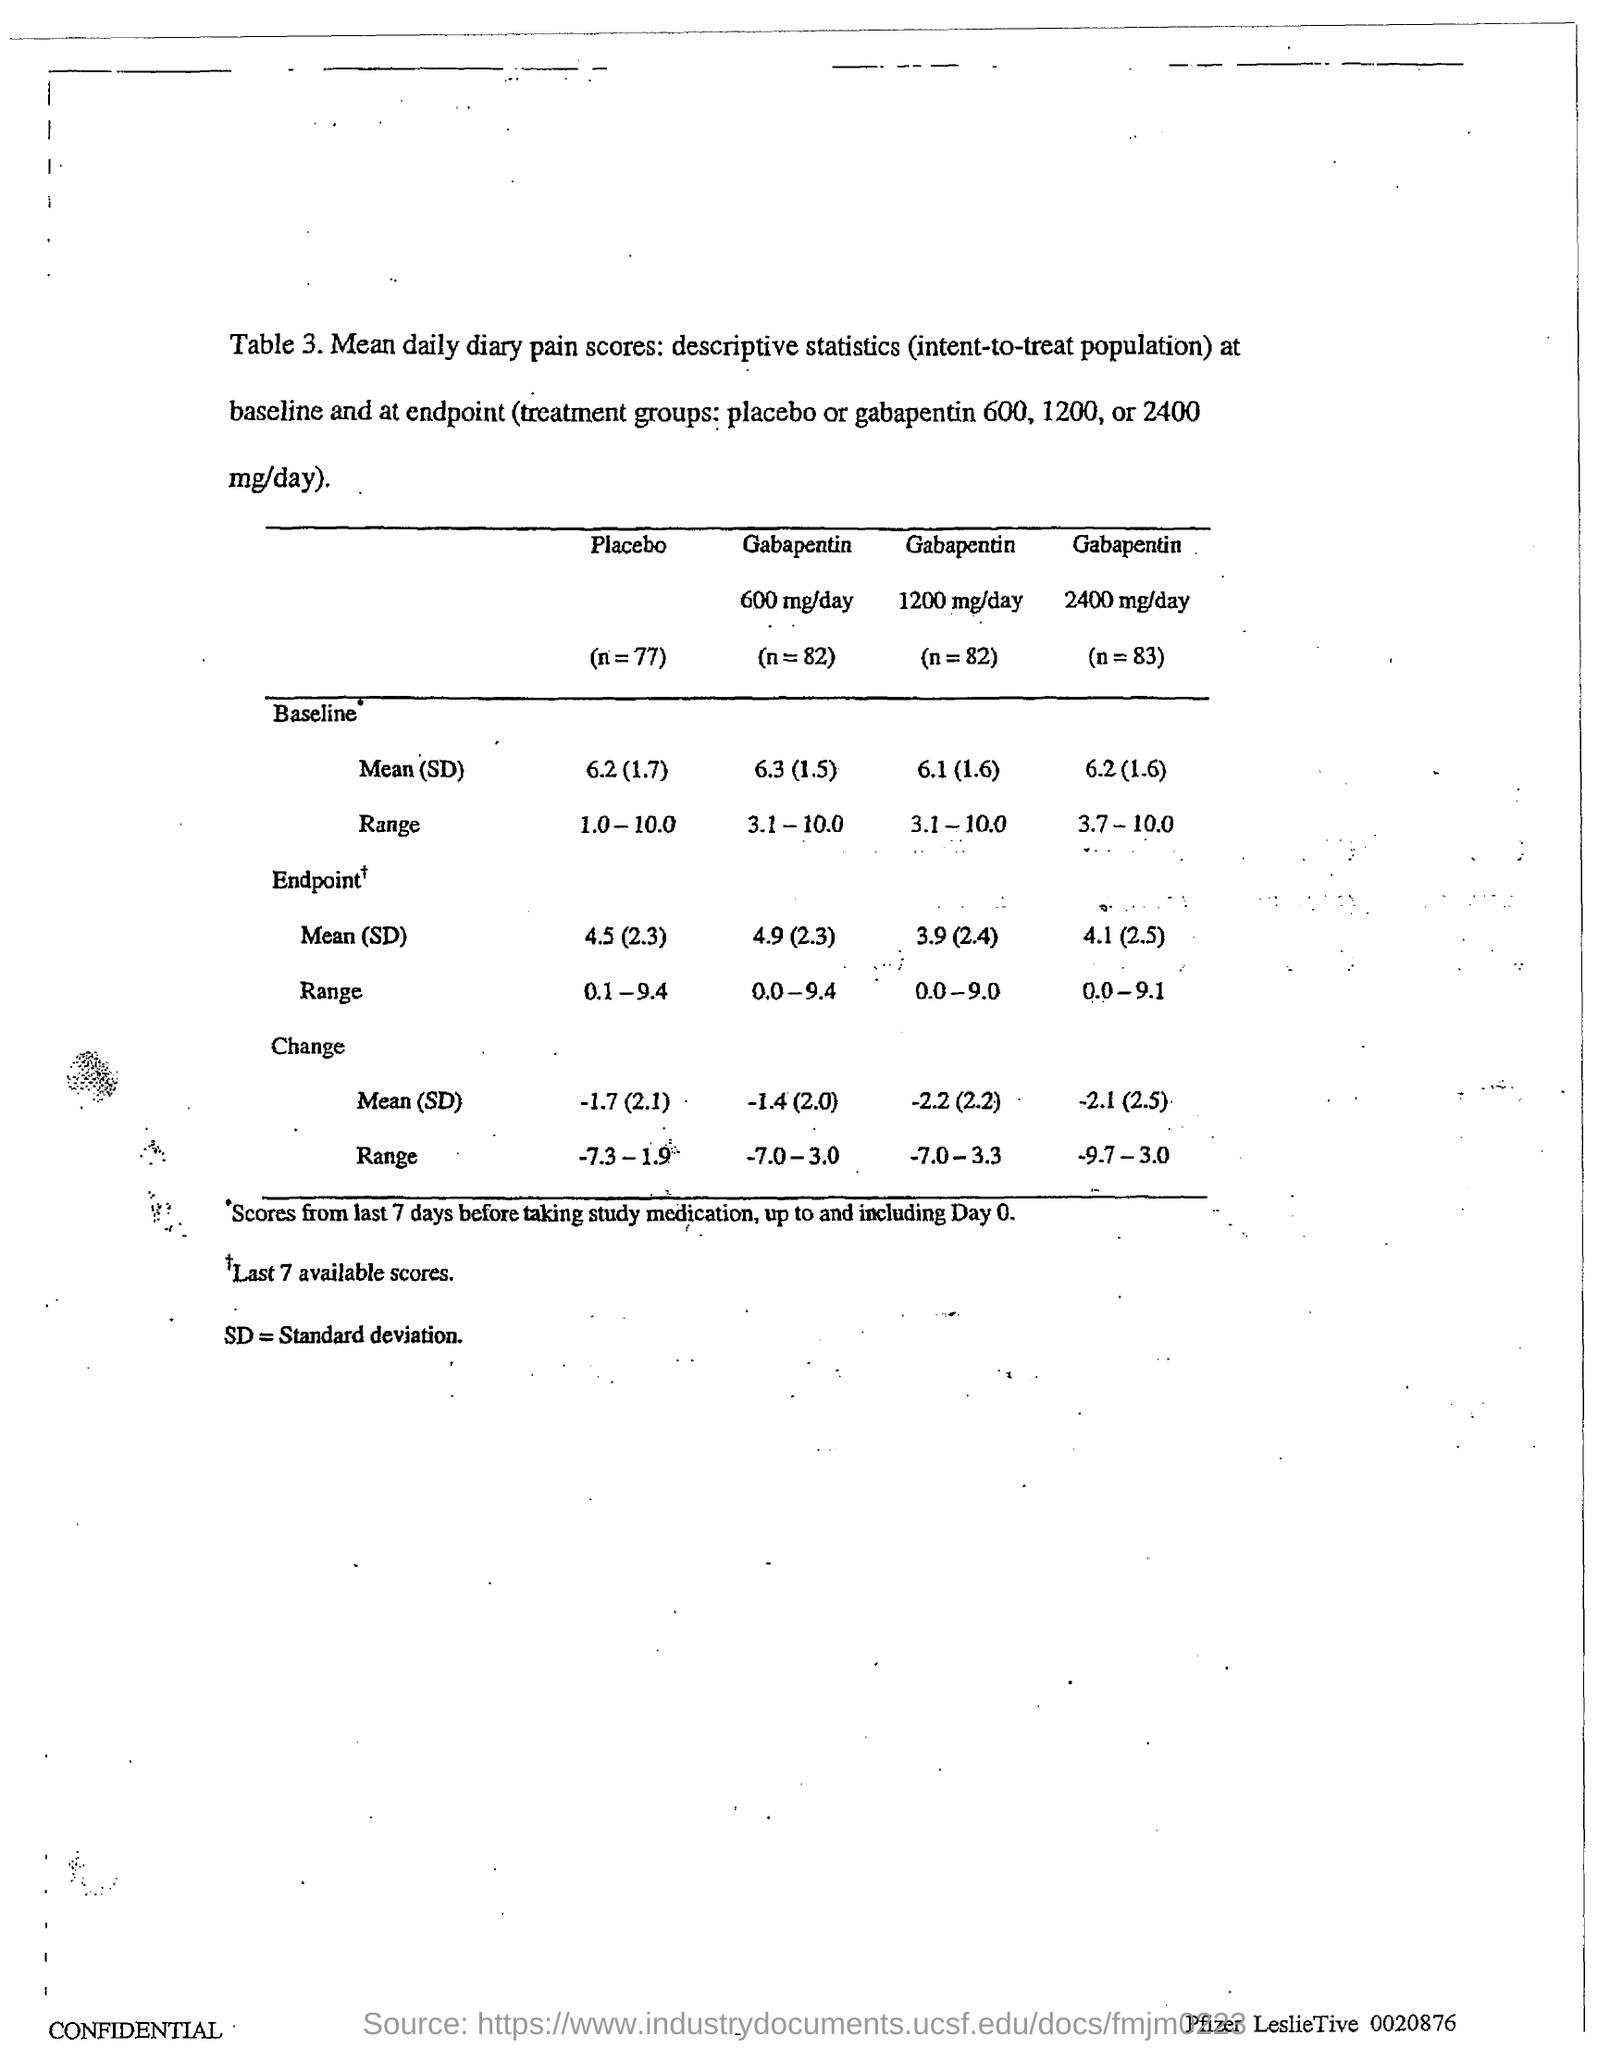What is sd =?
Give a very brief answer. Standard Deviation. 